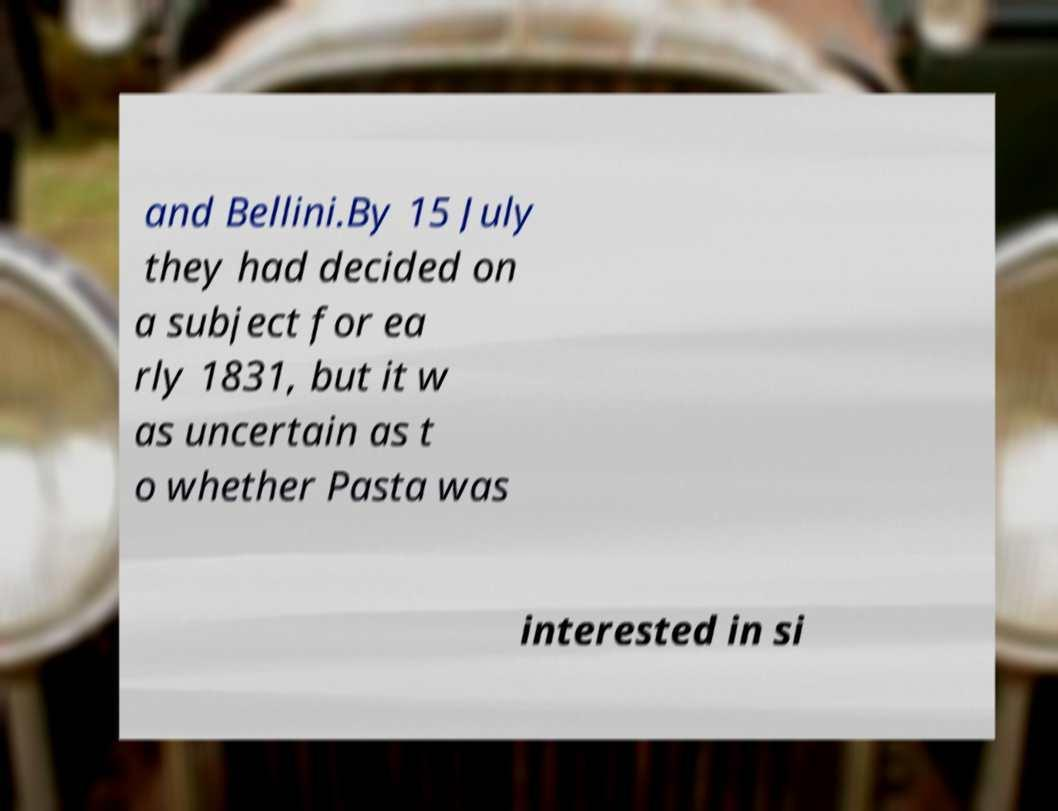Please read and relay the text visible in this image. What does it say? and Bellini.By 15 July they had decided on a subject for ea rly 1831, but it w as uncertain as t o whether Pasta was interested in si 